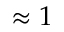Convert formula to latex. <formula><loc_0><loc_0><loc_500><loc_500>\approx 1</formula> 